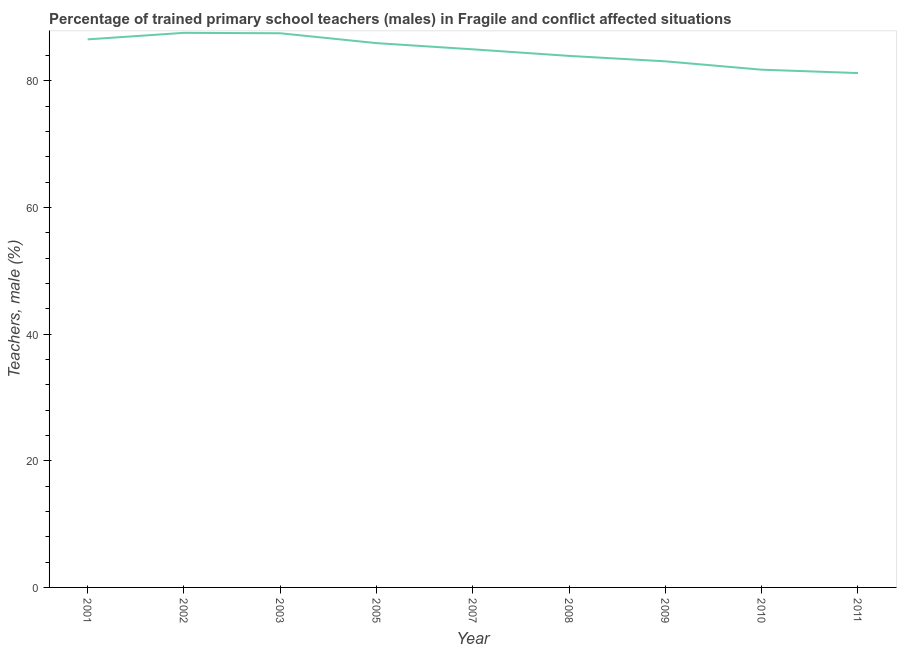What is the percentage of trained male teachers in 2010?
Offer a very short reply. 81.74. Across all years, what is the maximum percentage of trained male teachers?
Ensure brevity in your answer.  87.56. Across all years, what is the minimum percentage of trained male teachers?
Keep it short and to the point. 81.21. In which year was the percentage of trained male teachers minimum?
Provide a short and direct response. 2011. What is the sum of the percentage of trained male teachers?
Your answer should be compact. 762.42. What is the difference between the percentage of trained male teachers in 2002 and 2007?
Offer a terse response. 2.6. What is the average percentage of trained male teachers per year?
Give a very brief answer. 84.71. What is the median percentage of trained male teachers?
Ensure brevity in your answer.  84.96. What is the ratio of the percentage of trained male teachers in 2005 to that in 2011?
Provide a short and direct response. 1.06. Is the percentage of trained male teachers in 2005 less than that in 2011?
Provide a short and direct response. No. Is the difference between the percentage of trained male teachers in 2005 and 2007 greater than the difference between any two years?
Ensure brevity in your answer.  No. What is the difference between the highest and the second highest percentage of trained male teachers?
Your answer should be very brief. 0.07. What is the difference between the highest and the lowest percentage of trained male teachers?
Offer a terse response. 6.35. Does the percentage of trained male teachers monotonically increase over the years?
Ensure brevity in your answer.  No. Are the values on the major ticks of Y-axis written in scientific E-notation?
Your answer should be compact. No. Does the graph contain any zero values?
Provide a short and direct response. No. Does the graph contain grids?
Your response must be concise. No. What is the title of the graph?
Give a very brief answer. Percentage of trained primary school teachers (males) in Fragile and conflict affected situations. What is the label or title of the X-axis?
Your answer should be compact. Year. What is the label or title of the Y-axis?
Make the answer very short. Teachers, male (%). What is the Teachers, male (%) of 2001?
Offer a very short reply. 86.53. What is the Teachers, male (%) in 2002?
Ensure brevity in your answer.  87.56. What is the Teachers, male (%) in 2003?
Provide a short and direct response. 87.5. What is the Teachers, male (%) of 2005?
Provide a succinct answer. 85.94. What is the Teachers, male (%) of 2007?
Your answer should be very brief. 84.96. What is the Teachers, male (%) of 2008?
Your answer should be compact. 83.92. What is the Teachers, male (%) in 2009?
Make the answer very short. 83.06. What is the Teachers, male (%) in 2010?
Keep it short and to the point. 81.74. What is the Teachers, male (%) in 2011?
Give a very brief answer. 81.21. What is the difference between the Teachers, male (%) in 2001 and 2002?
Give a very brief answer. -1.03. What is the difference between the Teachers, male (%) in 2001 and 2003?
Provide a succinct answer. -0.96. What is the difference between the Teachers, male (%) in 2001 and 2005?
Your answer should be very brief. 0.59. What is the difference between the Teachers, male (%) in 2001 and 2007?
Offer a terse response. 1.57. What is the difference between the Teachers, male (%) in 2001 and 2008?
Offer a terse response. 2.61. What is the difference between the Teachers, male (%) in 2001 and 2009?
Offer a very short reply. 3.47. What is the difference between the Teachers, male (%) in 2001 and 2010?
Provide a short and direct response. 4.79. What is the difference between the Teachers, male (%) in 2001 and 2011?
Make the answer very short. 5.32. What is the difference between the Teachers, male (%) in 2002 and 2003?
Keep it short and to the point. 0.07. What is the difference between the Teachers, male (%) in 2002 and 2005?
Make the answer very short. 1.62. What is the difference between the Teachers, male (%) in 2002 and 2007?
Your answer should be very brief. 2.6. What is the difference between the Teachers, male (%) in 2002 and 2008?
Provide a succinct answer. 3.64. What is the difference between the Teachers, male (%) in 2002 and 2009?
Offer a terse response. 4.5. What is the difference between the Teachers, male (%) in 2002 and 2010?
Give a very brief answer. 5.82. What is the difference between the Teachers, male (%) in 2002 and 2011?
Provide a succinct answer. 6.35. What is the difference between the Teachers, male (%) in 2003 and 2005?
Give a very brief answer. 1.56. What is the difference between the Teachers, male (%) in 2003 and 2007?
Your answer should be very brief. 2.54. What is the difference between the Teachers, male (%) in 2003 and 2008?
Keep it short and to the point. 3.57. What is the difference between the Teachers, male (%) in 2003 and 2009?
Offer a terse response. 4.43. What is the difference between the Teachers, male (%) in 2003 and 2010?
Give a very brief answer. 5.75. What is the difference between the Teachers, male (%) in 2003 and 2011?
Offer a terse response. 6.28. What is the difference between the Teachers, male (%) in 2005 and 2007?
Provide a short and direct response. 0.98. What is the difference between the Teachers, male (%) in 2005 and 2008?
Your answer should be very brief. 2.02. What is the difference between the Teachers, male (%) in 2005 and 2009?
Your answer should be very brief. 2.87. What is the difference between the Teachers, male (%) in 2005 and 2010?
Your answer should be very brief. 4.2. What is the difference between the Teachers, male (%) in 2005 and 2011?
Offer a terse response. 4.73. What is the difference between the Teachers, male (%) in 2007 and 2008?
Make the answer very short. 1.04. What is the difference between the Teachers, male (%) in 2007 and 2009?
Offer a terse response. 1.9. What is the difference between the Teachers, male (%) in 2007 and 2010?
Your response must be concise. 3.22. What is the difference between the Teachers, male (%) in 2007 and 2011?
Your response must be concise. 3.75. What is the difference between the Teachers, male (%) in 2008 and 2009?
Offer a very short reply. 0.86. What is the difference between the Teachers, male (%) in 2008 and 2010?
Keep it short and to the point. 2.18. What is the difference between the Teachers, male (%) in 2008 and 2011?
Your response must be concise. 2.71. What is the difference between the Teachers, male (%) in 2009 and 2010?
Keep it short and to the point. 1.32. What is the difference between the Teachers, male (%) in 2009 and 2011?
Your response must be concise. 1.85. What is the difference between the Teachers, male (%) in 2010 and 2011?
Offer a terse response. 0.53. What is the ratio of the Teachers, male (%) in 2001 to that in 2002?
Your response must be concise. 0.99. What is the ratio of the Teachers, male (%) in 2001 to that in 2003?
Your response must be concise. 0.99. What is the ratio of the Teachers, male (%) in 2001 to that in 2005?
Offer a very short reply. 1.01. What is the ratio of the Teachers, male (%) in 2001 to that in 2007?
Offer a terse response. 1.02. What is the ratio of the Teachers, male (%) in 2001 to that in 2008?
Offer a very short reply. 1.03. What is the ratio of the Teachers, male (%) in 2001 to that in 2009?
Your response must be concise. 1.04. What is the ratio of the Teachers, male (%) in 2001 to that in 2010?
Make the answer very short. 1.06. What is the ratio of the Teachers, male (%) in 2001 to that in 2011?
Provide a succinct answer. 1.06. What is the ratio of the Teachers, male (%) in 2002 to that in 2005?
Offer a very short reply. 1.02. What is the ratio of the Teachers, male (%) in 2002 to that in 2007?
Keep it short and to the point. 1.03. What is the ratio of the Teachers, male (%) in 2002 to that in 2008?
Provide a short and direct response. 1.04. What is the ratio of the Teachers, male (%) in 2002 to that in 2009?
Provide a short and direct response. 1.05. What is the ratio of the Teachers, male (%) in 2002 to that in 2010?
Your response must be concise. 1.07. What is the ratio of the Teachers, male (%) in 2002 to that in 2011?
Your response must be concise. 1.08. What is the ratio of the Teachers, male (%) in 2003 to that in 2005?
Offer a terse response. 1.02. What is the ratio of the Teachers, male (%) in 2003 to that in 2007?
Your response must be concise. 1.03. What is the ratio of the Teachers, male (%) in 2003 to that in 2008?
Your answer should be very brief. 1.04. What is the ratio of the Teachers, male (%) in 2003 to that in 2009?
Ensure brevity in your answer.  1.05. What is the ratio of the Teachers, male (%) in 2003 to that in 2010?
Your response must be concise. 1.07. What is the ratio of the Teachers, male (%) in 2003 to that in 2011?
Offer a very short reply. 1.08. What is the ratio of the Teachers, male (%) in 2005 to that in 2007?
Provide a short and direct response. 1.01. What is the ratio of the Teachers, male (%) in 2005 to that in 2008?
Provide a succinct answer. 1.02. What is the ratio of the Teachers, male (%) in 2005 to that in 2009?
Your response must be concise. 1.03. What is the ratio of the Teachers, male (%) in 2005 to that in 2010?
Give a very brief answer. 1.05. What is the ratio of the Teachers, male (%) in 2005 to that in 2011?
Your answer should be compact. 1.06. What is the ratio of the Teachers, male (%) in 2007 to that in 2008?
Your answer should be very brief. 1.01. What is the ratio of the Teachers, male (%) in 2007 to that in 2010?
Make the answer very short. 1.04. What is the ratio of the Teachers, male (%) in 2007 to that in 2011?
Provide a short and direct response. 1.05. What is the ratio of the Teachers, male (%) in 2008 to that in 2010?
Ensure brevity in your answer.  1.03. What is the ratio of the Teachers, male (%) in 2008 to that in 2011?
Keep it short and to the point. 1.03. What is the ratio of the Teachers, male (%) in 2009 to that in 2011?
Provide a succinct answer. 1.02. What is the ratio of the Teachers, male (%) in 2010 to that in 2011?
Offer a very short reply. 1.01. 